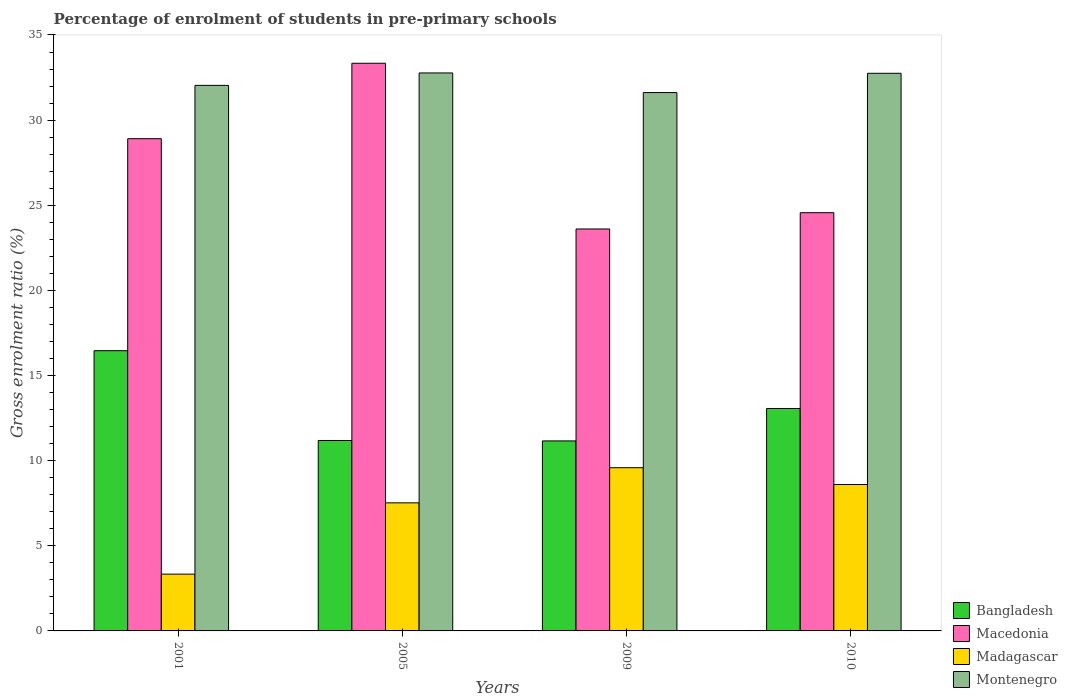How many different coloured bars are there?
Your response must be concise. 4. How many groups of bars are there?
Offer a very short reply. 4. Are the number of bars on each tick of the X-axis equal?
Provide a short and direct response. Yes. How many bars are there on the 1st tick from the left?
Offer a very short reply. 4. What is the label of the 1st group of bars from the left?
Your answer should be compact. 2001. In how many cases, is the number of bars for a given year not equal to the number of legend labels?
Provide a succinct answer. 0. What is the percentage of students enrolled in pre-primary schools in Bangladesh in 2009?
Keep it short and to the point. 11.16. Across all years, what is the maximum percentage of students enrolled in pre-primary schools in Montenegro?
Give a very brief answer. 32.77. Across all years, what is the minimum percentage of students enrolled in pre-primary schools in Montenegro?
Make the answer very short. 31.62. In which year was the percentage of students enrolled in pre-primary schools in Madagascar minimum?
Provide a short and direct response. 2001. What is the total percentage of students enrolled in pre-primary schools in Bangladesh in the graph?
Your response must be concise. 51.86. What is the difference between the percentage of students enrolled in pre-primary schools in Bangladesh in 2005 and that in 2009?
Offer a terse response. 0.02. What is the difference between the percentage of students enrolled in pre-primary schools in Macedonia in 2005 and the percentage of students enrolled in pre-primary schools in Montenegro in 2001?
Your answer should be very brief. 1.3. What is the average percentage of students enrolled in pre-primary schools in Madagascar per year?
Make the answer very short. 7.26. In the year 2010, what is the difference between the percentage of students enrolled in pre-primary schools in Madagascar and percentage of students enrolled in pre-primary schools in Macedonia?
Provide a succinct answer. -15.96. What is the ratio of the percentage of students enrolled in pre-primary schools in Montenegro in 2001 to that in 2005?
Offer a terse response. 0.98. What is the difference between the highest and the second highest percentage of students enrolled in pre-primary schools in Macedonia?
Provide a succinct answer. 4.43. What is the difference between the highest and the lowest percentage of students enrolled in pre-primary schools in Bangladesh?
Make the answer very short. 5.3. Is it the case that in every year, the sum of the percentage of students enrolled in pre-primary schools in Montenegro and percentage of students enrolled in pre-primary schools in Madagascar is greater than the sum of percentage of students enrolled in pre-primary schools in Macedonia and percentage of students enrolled in pre-primary schools in Bangladesh?
Offer a very short reply. No. What does the 1st bar from the left in 2005 represents?
Provide a succinct answer. Bangladesh. How many bars are there?
Offer a very short reply. 16. Are all the bars in the graph horizontal?
Give a very brief answer. No. What is the difference between two consecutive major ticks on the Y-axis?
Your answer should be compact. 5. Does the graph contain any zero values?
Offer a terse response. No. Where does the legend appear in the graph?
Ensure brevity in your answer.  Bottom right. How are the legend labels stacked?
Ensure brevity in your answer.  Vertical. What is the title of the graph?
Your answer should be very brief. Percentage of enrolment of students in pre-primary schools. What is the label or title of the X-axis?
Provide a short and direct response. Years. What is the Gross enrolment ratio (%) in Bangladesh in 2001?
Provide a short and direct response. 16.46. What is the Gross enrolment ratio (%) in Macedonia in 2001?
Provide a short and direct response. 28.91. What is the Gross enrolment ratio (%) of Madagascar in 2001?
Your response must be concise. 3.34. What is the Gross enrolment ratio (%) in Montenegro in 2001?
Offer a very short reply. 32.04. What is the Gross enrolment ratio (%) in Bangladesh in 2005?
Offer a terse response. 11.18. What is the Gross enrolment ratio (%) in Macedonia in 2005?
Offer a very short reply. 33.34. What is the Gross enrolment ratio (%) of Madagascar in 2005?
Offer a terse response. 7.52. What is the Gross enrolment ratio (%) in Montenegro in 2005?
Your answer should be compact. 32.77. What is the Gross enrolment ratio (%) of Bangladesh in 2009?
Keep it short and to the point. 11.16. What is the Gross enrolment ratio (%) of Macedonia in 2009?
Ensure brevity in your answer.  23.61. What is the Gross enrolment ratio (%) of Madagascar in 2009?
Offer a very short reply. 9.59. What is the Gross enrolment ratio (%) in Montenegro in 2009?
Your answer should be very brief. 31.62. What is the Gross enrolment ratio (%) of Bangladesh in 2010?
Make the answer very short. 13.06. What is the Gross enrolment ratio (%) in Macedonia in 2010?
Your response must be concise. 24.56. What is the Gross enrolment ratio (%) in Madagascar in 2010?
Your answer should be very brief. 8.6. What is the Gross enrolment ratio (%) in Montenegro in 2010?
Your response must be concise. 32.75. Across all years, what is the maximum Gross enrolment ratio (%) of Bangladesh?
Offer a very short reply. 16.46. Across all years, what is the maximum Gross enrolment ratio (%) in Macedonia?
Give a very brief answer. 33.34. Across all years, what is the maximum Gross enrolment ratio (%) in Madagascar?
Provide a short and direct response. 9.59. Across all years, what is the maximum Gross enrolment ratio (%) in Montenegro?
Ensure brevity in your answer.  32.77. Across all years, what is the minimum Gross enrolment ratio (%) in Bangladesh?
Your answer should be compact. 11.16. Across all years, what is the minimum Gross enrolment ratio (%) of Macedonia?
Offer a terse response. 23.61. Across all years, what is the minimum Gross enrolment ratio (%) in Madagascar?
Ensure brevity in your answer.  3.34. Across all years, what is the minimum Gross enrolment ratio (%) of Montenegro?
Make the answer very short. 31.62. What is the total Gross enrolment ratio (%) in Bangladesh in the graph?
Offer a terse response. 51.86. What is the total Gross enrolment ratio (%) in Macedonia in the graph?
Make the answer very short. 110.42. What is the total Gross enrolment ratio (%) of Madagascar in the graph?
Make the answer very short. 29.04. What is the total Gross enrolment ratio (%) of Montenegro in the graph?
Keep it short and to the point. 129.18. What is the difference between the Gross enrolment ratio (%) in Bangladesh in 2001 and that in 2005?
Your answer should be very brief. 5.27. What is the difference between the Gross enrolment ratio (%) in Macedonia in 2001 and that in 2005?
Give a very brief answer. -4.43. What is the difference between the Gross enrolment ratio (%) of Madagascar in 2001 and that in 2005?
Provide a short and direct response. -4.19. What is the difference between the Gross enrolment ratio (%) of Montenegro in 2001 and that in 2005?
Provide a succinct answer. -0.73. What is the difference between the Gross enrolment ratio (%) in Bangladesh in 2001 and that in 2009?
Provide a succinct answer. 5.3. What is the difference between the Gross enrolment ratio (%) in Macedonia in 2001 and that in 2009?
Your answer should be compact. 5.3. What is the difference between the Gross enrolment ratio (%) of Madagascar in 2001 and that in 2009?
Your answer should be very brief. -6.25. What is the difference between the Gross enrolment ratio (%) in Montenegro in 2001 and that in 2009?
Provide a short and direct response. 0.42. What is the difference between the Gross enrolment ratio (%) of Bangladesh in 2001 and that in 2010?
Give a very brief answer. 3.39. What is the difference between the Gross enrolment ratio (%) of Macedonia in 2001 and that in 2010?
Give a very brief answer. 4.35. What is the difference between the Gross enrolment ratio (%) in Madagascar in 2001 and that in 2010?
Offer a terse response. -5.26. What is the difference between the Gross enrolment ratio (%) of Montenegro in 2001 and that in 2010?
Your answer should be very brief. -0.71. What is the difference between the Gross enrolment ratio (%) of Bangladesh in 2005 and that in 2009?
Your response must be concise. 0.02. What is the difference between the Gross enrolment ratio (%) of Macedonia in 2005 and that in 2009?
Your response must be concise. 9.73. What is the difference between the Gross enrolment ratio (%) of Madagascar in 2005 and that in 2009?
Provide a short and direct response. -2.06. What is the difference between the Gross enrolment ratio (%) of Montenegro in 2005 and that in 2009?
Offer a very short reply. 1.15. What is the difference between the Gross enrolment ratio (%) of Bangladesh in 2005 and that in 2010?
Ensure brevity in your answer.  -1.88. What is the difference between the Gross enrolment ratio (%) of Macedonia in 2005 and that in 2010?
Your answer should be compact. 8.78. What is the difference between the Gross enrolment ratio (%) in Madagascar in 2005 and that in 2010?
Provide a succinct answer. -1.08. What is the difference between the Gross enrolment ratio (%) in Montenegro in 2005 and that in 2010?
Give a very brief answer. 0.02. What is the difference between the Gross enrolment ratio (%) of Bangladesh in 2009 and that in 2010?
Your answer should be very brief. -1.9. What is the difference between the Gross enrolment ratio (%) in Macedonia in 2009 and that in 2010?
Provide a succinct answer. -0.96. What is the difference between the Gross enrolment ratio (%) in Madagascar in 2009 and that in 2010?
Your response must be concise. 0.99. What is the difference between the Gross enrolment ratio (%) of Montenegro in 2009 and that in 2010?
Offer a very short reply. -1.13. What is the difference between the Gross enrolment ratio (%) in Bangladesh in 2001 and the Gross enrolment ratio (%) in Macedonia in 2005?
Make the answer very short. -16.88. What is the difference between the Gross enrolment ratio (%) of Bangladesh in 2001 and the Gross enrolment ratio (%) of Madagascar in 2005?
Ensure brevity in your answer.  8.94. What is the difference between the Gross enrolment ratio (%) of Bangladesh in 2001 and the Gross enrolment ratio (%) of Montenegro in 2005?
Your answer should be compact. -16.31. What is the difference between the Gross enrolment ratio (%) of Macedonia in 2001 and the Gross enrolment ratio (%) of Madagascar in 2005?
Ensure brevity in your answer.  21.39. What is the difference between the Gross enrolment ratio (%) of Macedonia in 2001 and the Gross enrolment ratio (%) of Montenegro in 2005?
Your response must be concise. -3.86. What is the difference between the Gross enrolment ratio (%) of Madagascar in 2001 and the Gross enrolment ratio (%) of Montenegro in 2005?
Your answer should be compact. -29.44. What is the difference between the Gross enrolment ratio (%) of Bangladesh in 2001 and the Gross enrolment ratio (%) of Macedonia in 2009?
Your answer should be compact. -7.15. What is the difference between the Gross enrolment ratio (%) of Bangladesh in 2001 and the Gross enrolment ratio (%) of Madagascar in 2009?
Provide a short and direct response. 6.87. What is the difference between the Gross enrolment ratio (%) of Bangladesh in 2001 and the Gross enrolment ratio (%) of Montenegro in 2009?
Offer a very short reply. -15.16. What is the difference between the Gross enrolment ratio (%) of Macedonia in 2001 and the Gross enrolment ratio (%) of Madagascar in 2009?
Give a very brief answer. 19.32. What is the difference between the Gross enrolment ratio (%) in Macedonia in 2001 and the Gross enrolment ratio (%) in Montenegro in 2009?
Make the answer very short. -2.71. What is the difference between the Gross enrolment ratio (%) in Madagascar in 2001 and the Gross enrolment ratio (%) in Montenegro in 2009?
Offer a very short reply. -28.28. What is the difference between the Gross enrolment ratio (%) in Bangladesh in 2001 and the Gross enrolment ratio (%) in Macedonia in 2010?
Ensure brevity in your answer.  -8.1. What is the difference between the Gross enrolment ratio (%) of Bangladesh in 2001 and the Gross enrolment ratio (%) of Madagascar in 2010?
Your response must be concise. 7.86. What is the difference between the Gross enrolment ratio (%) in Bangladesh in 2001 and the Gross enrolment ratio (%) in Montenegro in 2010?
Offer a very short reply. -16.29. What is the difference between the Gross enrolment ratio (%) of Macedonia in 2001 and the Gross enrolment ratio (%) of Madagascar in 2010?
Give a very brief answer. 20.31. What is the difference between the Gross enrolment ratio (%) in Macedonia in 2001 and the Gross enrolment ratio (%) in Montenegro in 2010?
Your response must be concise. -3.84. What is the difference between the Gross enrolment ratio (%) in Madagascar in 2001 and the Gross enrolment ratio (%) in Montenegro in 2010?
Offer a very short reply. -29.42. What is the difference between the Gross enrolment ratio (%) of Bangladesh in 2005 and the Gross enrolment ratio (%) of Macedonia in 2009?
Give a very brief answer. -12.42. What is the difference between the Gross enrolment ratio (%) in Bangladesh in 2005 and the Gross enrolment ratio (%) in Madagascar in 2009?
Provide a short and direct response. 1.6. What is the difference between the Gross enrolment ratio (%) in Bangladesh in 2005 and the Gross enrolment ratio (%) in Montenegro in 2009?
Provide a short and direct response. -20.43. What is the difference between the Gross enrolment ratio (%) in Macedonia in 2005 and the Gross enrolment ratio (%) in Madagascar in 2009?
Your answer should be compact. 23.75. What is the difference between the Gross enrolment ratio (%) in Macedonia in 2005 and the Gross enrolment ratio (%) in Montenegro in 2009?
Your answer should be very brief. 1.72. What is the difference between the Gross enrolment ratio (%) of Madagascar in 2005 and the Gross enrolment ratio (%) of Montenegro in 2009?
Provide a succinct answer. -24.1. What is the difference between the Gross enrolment ratio (%) in Bangladesh in 2005 and the Gross enrolment ratio (%) in Macedonia in 2010?
Give a very brief answer. -13.38. What is the difference between the Gross enrolment ratio (%) of Bangladesh in 2005 and the Gross enrolment ratio (%) of Madagascar in 2010?
Provide a succinct answer. 2.58. What is the difference between the Gross enrolment ratio (%) of Bangladesh in 2005 and the Gross enrolment ratio (%) of Montenegro in 2010?
Ensure brevity in your answer.  -21.57. What is the difference between the Gross enrolment ratio (%) in Macedonia in 2005 and the Gross enrolment ratio (%) in Madagascar in 2010?
Offer a terse response. 24.74. What is the difference between the Gross enrolment ratio (%) in Macedonia in 2005 and the Gross enrolment ratio (%) in Montenegro in 2010?
Your answer should be compact. 0.59. What is the difference between the Gross enrolment ratio (%) in Madagascar in 2005 and the Gross enrolment ratio (%) in Montenegro in 2010?
Keep it short and to the point. -25.23. What is the difference between the Gross enrolment ratio (%) in Bangladesh in 2009 and the Gross enrolment ratio (%) in Macedonia in 2010?
Offer a very short reply. -13.4. What is the difference between the Gross enrolment ratio (%) in Bangladesh in 2009 and the Gross enrolment ratio (%) in Madagascar in 2010?
Keep it short and to the point. 2.56. What is the difference between the Gross enrolment ratio (%) of Bangladesh in 2009 and the Gross enrolment ratio (%) of Montenegro in 2010?
Provide a short and direct response. -21.59. What is the difference between the Gross enrolment ratio (%) of Macedonia in 2009 and the Gross enrolment ratio (%) of Madagascar in 2010?
Your answer should be very brief. 15.01. What is the difference between the Gross enrolment ratio (%) of Macedonia in 2009 and the Gross enrolment ratio (%) of Montenegro in 2010?
Ensure brevity in your answer.  -9.14. What is the difference between the Gross enrolment ratio (%) in Madagascar in 2009 and the Gross enrolment ratio (%) in Montenegro in 2010?
Provide a short and direct response. -23.17. What is the average Gross enrolment ratio (%) of Bangladesh per year?
Your answer should be compact. 12.97. What is the average Gross enrolment ratio (%) in Macedonia per year?
Give a very brief answer. 27.6. What is the average Gross enrolment ratio (%) of Madagascar per year?
Provide a succinct answer. 7.26. What is the average Gross enrolment ratio (%) of Montenegro per year?
Offer a terse response. 32.3. In the year 2001, what is the difference between the Gross enrolment ratio (%) in Bangladesh and Gross enrolment ratio (%) in Macedonia?
Make the answer very short. -12.45. In the year 2001, what is the difference between the Gross enrolment ratio (%) in Bangladesh and Gross enrolment ratio (%) in Madagascar?
Provide a succinct answer. 13.12. In the year 2001, what is the difference between the Gross enrolment ratio (%) of Bangladesh and Gross enrolment ratio (%) of Montenegro?
Ensure brevity in your answer.  -15.58. In the year 2001, what is the difference between the Gross enrolment ratio (%) in Macedonia and Gross enrolment ratio (%) in Madagascar?
Your answer should be compact. 25.57. In the year 2001, what is the difference between the Gross enrolment ratio (%) of Macedonia and Gross enrolment ratio (%) of Montenegro?
Provide a short and direct response. -3.13. In the year 2001, what is the difference between the Gross enrolment ratio (%) of Madagascar and Gross enrolment ratio (%) of Montenegro?
Ensure brevity in your answer.  -28.71. In the year 2005, what is the difference between the Gross enrolment ratio (%) in Bangladesh and Gross enrolment ratio (%) in Macedonia?
Keep it short and to the point. -22.16. In the year 2005, what is the difference between the Gross enrolment ratio (%) of Bangladesh and Gross enrolment ratio (%) of Madagascar?
Your response must be concise. 3.66. In the year 2005, what is the difference between the Gross enrolment ratio (%) in Bangladesh and Gross enrolment ratio (%) in Montenegro?
Your response must be concise. -21.59. In the year 2005, what is the difference between the Gross enrolment ratio (%) of Macedonia and Gross enrolment ratio (%) of Madagascar?
Keep it short and to the point. 25.82. In the year 2005, what is the difference between the Gross enrolment ratio (%) of Macedonia and Gross enrolment ratio (%) of Montenegro?
Provide a short and direct response. 0.57. In the year 2005, what is the difference between the Gross enrolment ratio (%) of Madagascar and Gross enrolment ratio (%) of Montenegro?
Offer a terse response. -25.25. In the year 2009, what is the difference between the Gross enrolment ratio (%) of Bangladesh and Gross enrolment ratio (%) of Macedonia?
Provide a succinct answer. -12.45. In the year 2009, what is the difference between the Gross enrolment ratio (%) in Bangladesh and Gross enrolment ratio (%) in Madagascar?
Offer a very short reply. 1.57. In the year 2009, what is the difference between the Gross enrolment ratio (%) of Bangladesh and Gross enrolment ratio (%) of Montenegro?
Your answer should be very brief. -20.46. In the year 2009, what is the difference between the Gross enrolment ratio (%) in Macedonia and Gross enrolment ratio (%) in Madagascar?
Ensure brevity in your answer.  14.02. In the year 2009, what is the difference between the Gross enrolment ratio (%) of Macedonia and Gross enrolment ratio (%) of Montenegro?
Keep it short and to the point. -8.01. In the year 2009, what is the difference between the Gross enrolment ratio (%) in Madagascar and Gross enrolment ratio (%) in Montenegro?
Make the answer very short. -22.03. In the year 2010, what is the difference between the Gross enrolment ratio (%) of Bangladesh and Gross enrolment ratio (%) of Macedonia?
Keep it short and to the point. -11.5. In the year 2010, what is the difference between the Gross enrolment ratio (%) of Bangladesh and Gross enrolment ratio (%) of Madagascar?
Your answer should be very brief. 4.46. In the year 2010, what is the difference between the Gross enrolment ratio (%) of Bangladesh and Gross enrolment ratio (%) of Montenegro?
Your answer should be compact. -19.69. In the year 2010, what is the difference between the Gross enrolment ratio (%) of Macedonia and Gross enrolment ratio (%) of Madagascar?
Your answer should be very brief. 15.96. In the year 2010, what is the difference between the Gross enrolment ratio (%) of Macedonia and Gross enrolment ratio (%) of Montenegro?
Your response must be concise. -8.19. In the year 2010, what is the difference between the Gross enrolment ratio (%) in Madagascar and Gross enrolment ratio (%) in Montenegro?
Your answer should be very brief. -24.15. What is the ratio of the Gross enrolment ratio (%) in Bangladesh in 2001 to that in 2005?
Your response must be concise. 1.47. What is the ratio of the Gross enrolment ratio (%) in Macedonia in 2001 to that in 2005?
Ensure brevity in your answer.  0.87. What is the ratio of the Gross enrolment ratio (%) in Madagascar in 2001 to that in 2005?
Your response must be concise. 0.44. What is the ratio of the Gross enrolment ratio (%) in Montenegro in 2001 to that in 2005?
Your answer should be very brief. 0.98. What is the ratio of the Gross enrolment ratio (%) of Bangladesh in 2001 to that in 2009?
Make the answer very short. 1.47. What is the ratio of the Gross enrolment ratio (%) in Macedonia in 2001 to that in 2009?
Offer a terse response. 1.22. What is the ratio of the Gross enrolment ratio (%) of Madagascar in 2001 to that in 2009?
Offer a terse response. 0.35. What is the ratio of the Gross enrolment ratio (%) in Montenegro in 2001 to that in 2009?
Your answer should be very brief. 1.01. What is the ratio of the Gross enrolment ratio (%) of Bangladesh in 2001 to that in 2010?
Give a very brief answer. 1.26. What is the ratio of the Gross enrolment ratio (%) in Macedonia in 2001 to that in 2010?
Give a very brief answer. 1.18. What is the ratio of the Gross enrolment ratio (%) of Madagascar in 2001 to that in 2010?
Give a very brief answer. 0.39. What is the ratio of the Gross enrolment ratio (%) of Montenegro in 2001 to that in 2010?
Your answer should be compact. 0.98. What is the ratio of the Gross enrolment ratio (%) of Macedonia in 2005 to that in 2009?
Offer a terse response. 1.41. What is the ratio of the Gross enrolment ratio (%) of Madagascar in 2005 to that in 2009?
Your answer should be very brief. 0.78. What is the ratio of the Gross enrolment ratio (%) in Montenegro in 2005 to that in 2009?
Offer a very short reply. 1.04. What is the ratio of the Gross enrolment ratio (%) in Bangladesh in 2005 to that in 2010?
Provide a short and direct response. 0.86. What is the ratio of the Gross enrolment ratio (%) of Macedonia in 2005 to that in 2010?
Your response must be concise. 1.36. What is the ratio of the Gross enrolment ratio (%) in Madagascar in 2005 to that in 2010?
Keep it short and to the point. 0.87. What is the ratio of the Gross enrolment ratio (%) in Bangladesh in 2009 to that in 2010?
Offer a terse response. 0.85. What is the ratio of the Gross enrolment ratio (%) of Macedonia in 2009 to that in 2010?
Make the answer very short. 0.96. What is the ratio of the Gross enrolment ratio (%) of Madagascar in 2009 to that in 2010?
Keep it short and to the point. 1.11. What is the ratio of the Gross enrolment ratio (%) in Montenegro in 2009 to that in 2010?
Give a very brief answer. 0.97. What is the difference between the highest and the second highest Gross enrolment ratio (%) of Bangladesh?
Your answer should be compact. 3.39. What is the difference between the highest and the second highest Gross enrolment ratio (%) in Macedonia?
Offer a very short reply. 4.43. What is the difference between the highest and the second highest Gross enrolment ratio (%) in Madagascar?
Make the answer very short. 0.99. What is the difference between the highest and the second highest Gross enrolment ratio (%) in Montenegro?
Your answer should be very brief. 0.02. What is the difference between the highest and the lowest Gross enrolment ratio (%) in Bangladesh?
Provide a succinct answer. 5.3. What is the difference between the highest and the lowest Gross enrolment ratio (%) of Macedonia?
Your response must be concise. 9.73. What is the difference between the highest and the lowest Gross enrolment ratio (%) in Madagascar?
Provide a short and direct response. 6.25. What is the difference between the highest and the lowest Gross enrolment ratio (%) in Montenegro?
Give a very brief answer. 1.15. 